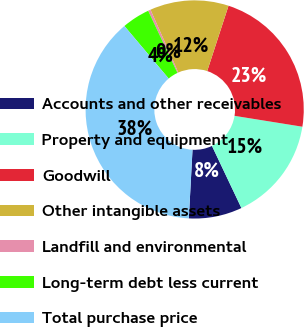<chart> <loc_0><loc_0><loc_500><loc_500><pie_chart><fcel>Accounts and other receivables<fcel>Property and equipment<fcel>Goodwill<fcel>Other intangible assets<fcel>Landfill and environmental<fcel>Long-term debt less current<fcel>Total purchase price<nl><fcel>7.9%<fcel>15.42%<fcel>22.51%<fcel>11.66%<fcel>0.37%<fcel>4.13%<fcel>38.01%<nl></chart> 